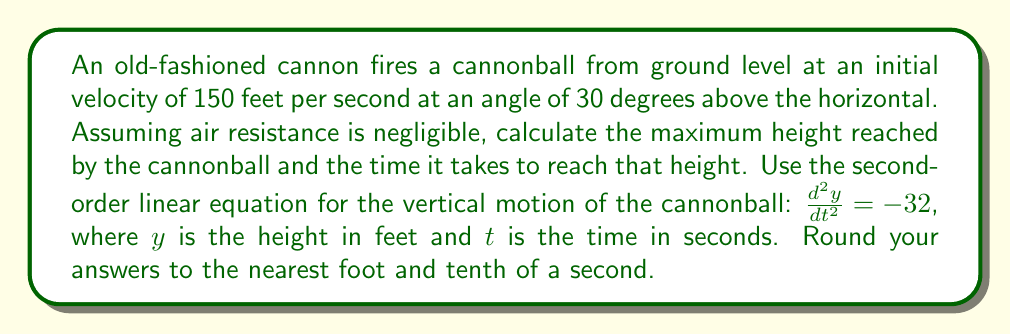Give your solution to this math problem. Let's approach this problem step-by-step using traditional methods:

1) First, we need to find the initial vertical velocity. Given the initial velocity of 150 ft/s at 30 degrees:
   $v_0y = 150 \sin(30°) = 150 * 0.5 = 75$ ft/s

2) The second-order linear equation for vertical motion is:
   $$\frac{d^2y}{dt^2} = -32$$

3) Integrating once gives us the velocity equation:
   $$\frac{dy}{dt} = -32t + C_1$$
   Where $C_1$ is the initial vertical velocity, 75 ft/s.

4) Integrating again gives us the position equation:
   $$y = -16t^2 + 75t + C_2$$
   Where $C_2$ is the initial height, 0 ft.

5) To find the maximum height, we need to find when the vertical velocity is zero:
   $$0 = -32t + 75$$
   $$t = \frac{75}{32} = 2.34375$$  seconds

6) Substituting this time back into the position equation:
   $$y = -16(2.34375)^2 + 75(2.34375) + 0$$
   $$y = -87.89 + 175.78 = 87.89$$ feet

Therefore, the maximum height is approximately 88 feet, reached after about 2.3 seconds.
Answer: Maximum height: 88 feet
Time to reach maximum height: 2.3 seconds 